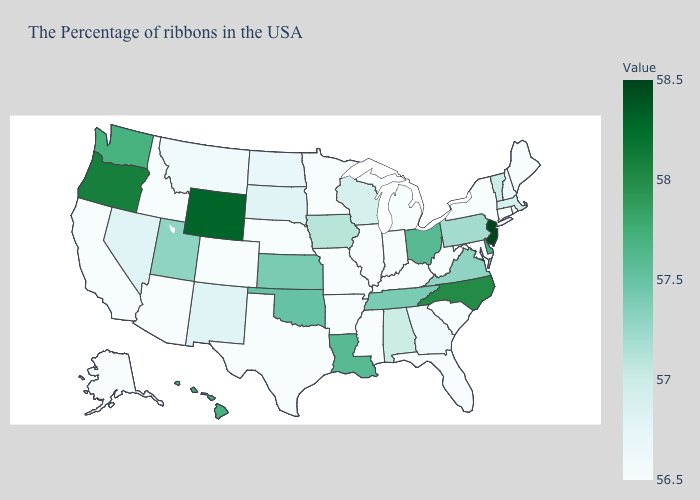Among the states that border Kansas , does Nebraska have the highest value?
Answer briefly. No. Is the legend a continuous bar?
Short answer required. Yes. Which states have the lowest value in the Northeast?
Concise answer only. Maine, Rhode Island, Connecticut, New York. Among the states that border Colorado , which have the highest value?
Write a very short answer. Wyoming. 